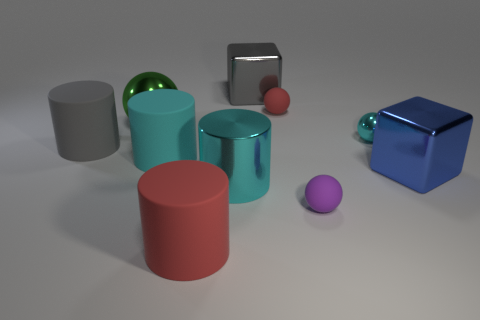Subtract 1 cylinders. How many cylinders are left? 3 Subtract all purple balls. How many balls are left? 3 Subtract all small balls. How many balls are left? 1 Subtract all brown cylinders. Subtract all brown balls. How many cylinders are left? 4 Subtract all cubes. How many objects are left? 8 Add 10 tiny brown matte cubes. How many tiny brown matte cubes exist? 10 Subtract 0 blue spheres. How many objects are left? 10 Subtract all gray rubber cylinders. Subtract all large blue shiny things. How many objects are left? 8 Add 7 small cyan metallic things. How many small cyan metallic things are left? 8 